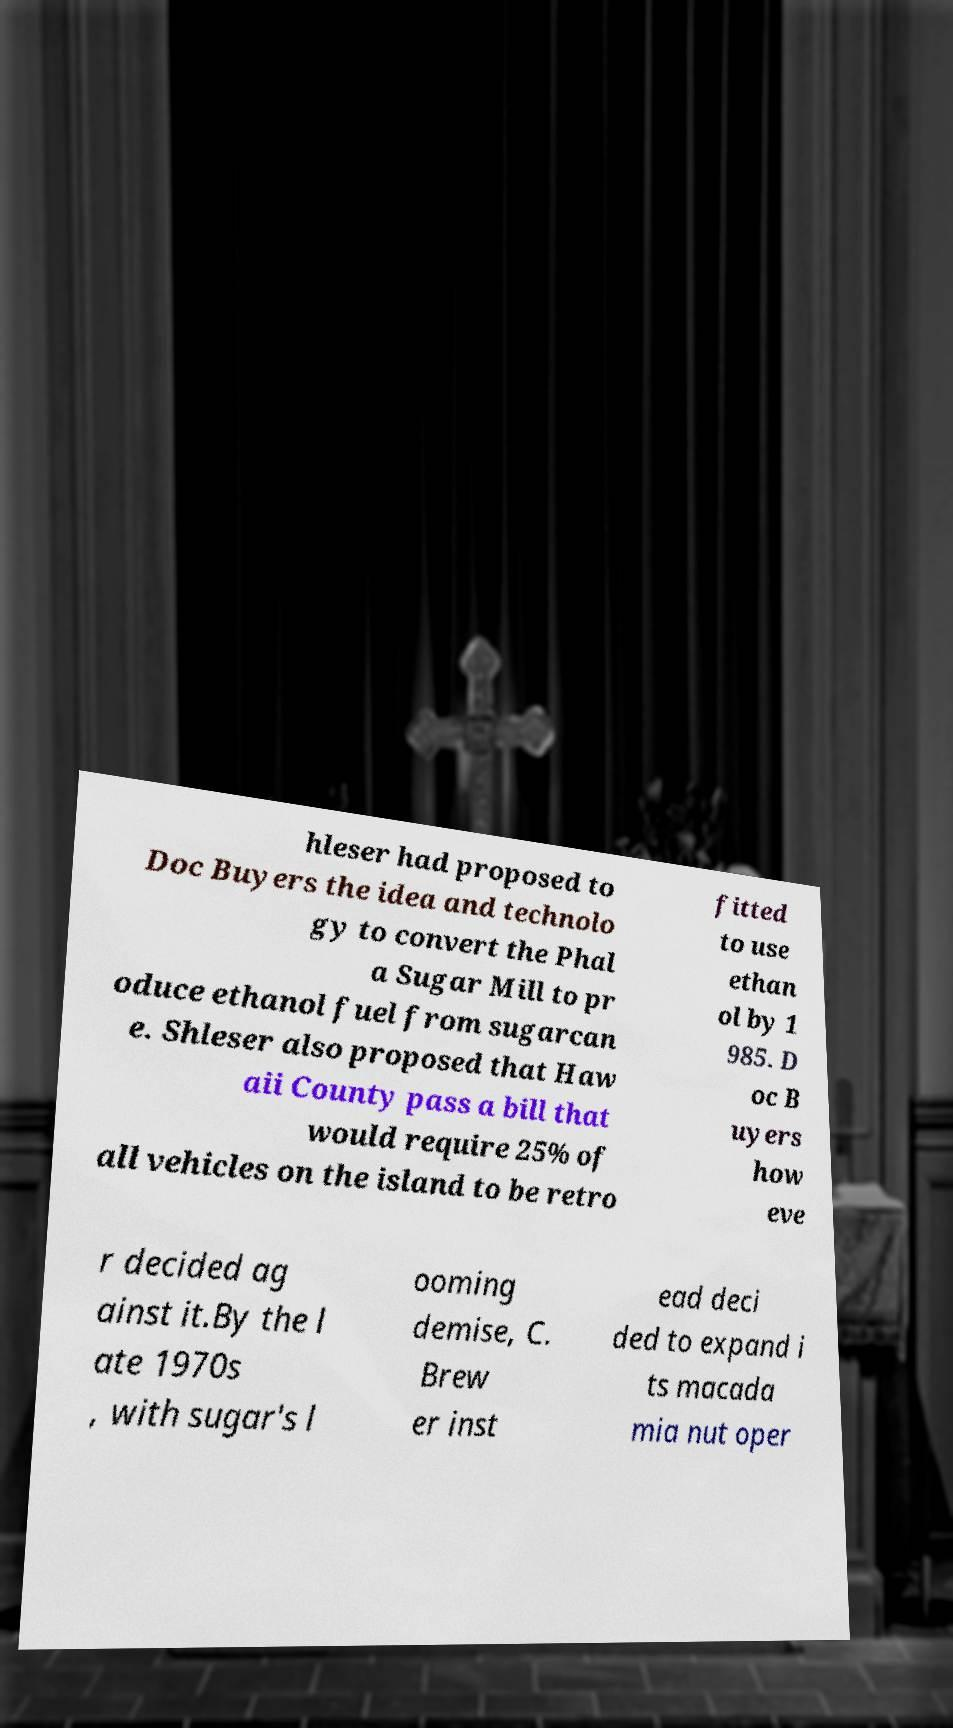For documentation purposes, I need the text within this image transcribed. Could you provide that? hleser had proposed to Doc Buyers the idea and technolo gy to convert the Phal a Sugar Mill to pr oduce ethanol fuel from sugarcan e. Shleser also proposed that Haw aii County pass a bill that would require 25% of all vehicles on the island to be retro fitted to use ethan ol by 1 985. D oc B uyers how eve r decided ag ainst it.By the l ate 1970s , with sugar's l ooming demise, C. Brew er inst ead deci ded to expand i ts macada mia nut oper 